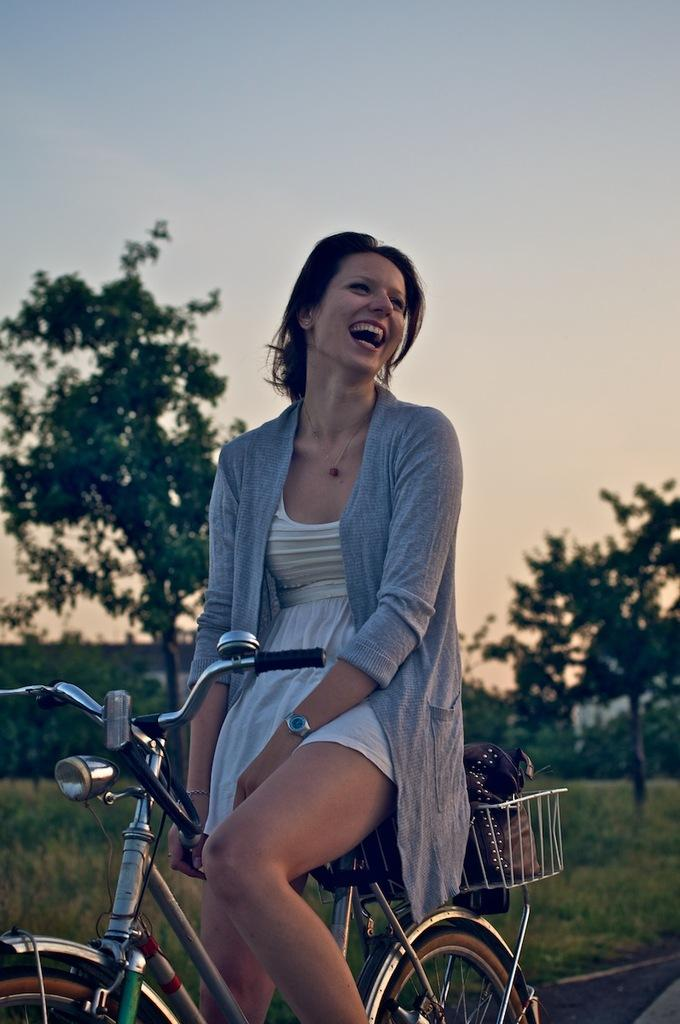Who is present in the image? There is a woman in the image. What is the woman doing in the image? The woman is sitting on a bicycle. What is the woman's facial expression in the image? The woman is smiling. What can be seen in the background of the image? There are trees in the background of the image. What type of terrain is visible in the image? There is grass visible in the image. What part of the natural environment is visible in the image? The sky is visible in the image. What type of mask is the woman wearing in the image? There is no mask visible in the image; the woman is not wearing one. What thrilling activity is the woman participating in the image? The image does not depict a thrilling activity; the woman is simply sitting on a bicycle. 